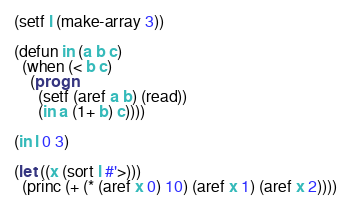<code> <loc_0><loc_0><loc_500><loc_500><_Lisp_>(setf l (make-array 3))

(defun in (a b c)
  (when (< b c)
	(progn 
	  (setf (aref a b) (read))
	  (in a (1+ b) c))))

(in l 0 3)

(let ((x (sort l #'>)))
  (princ (+ (* (aref x 0) 10) (aref x 1) (aref x 2))))
</code> 